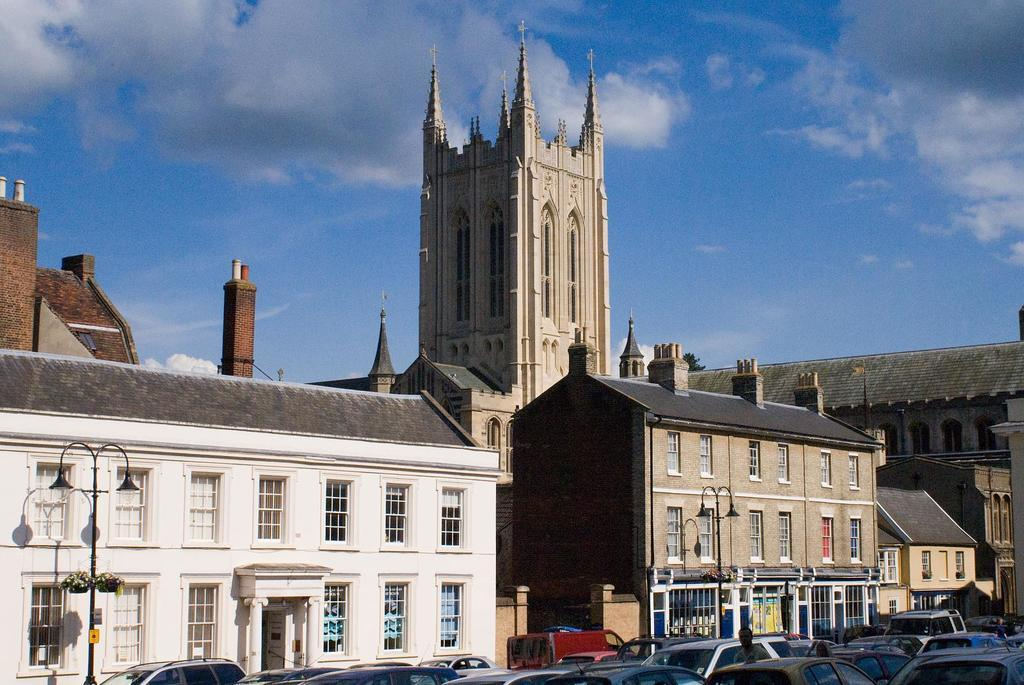What types of objects are at the bottom of the image? There are vehicles at the bottom of the image. Can you describe the people in the image? There are people in the image. What can be seen in the background of the image? There are buildings, light poles, windows, doors, glass doors, and roofs visible in the background of the image. What is the condition of the sky in the background of the image? Clouds are visible in the sky in the background of the image. Is there any quicksand visible in the image? No, there is no quicksand present in the image. How many friends are visible in the image? There is no mention of friends in the image, only people. What is in the pocket of the person in the image? There is no information about a pocket or its contents in the image. 